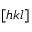<formula> <loc_0><loc_0><loc_500><loc_500>[ h k l ]</formula> 